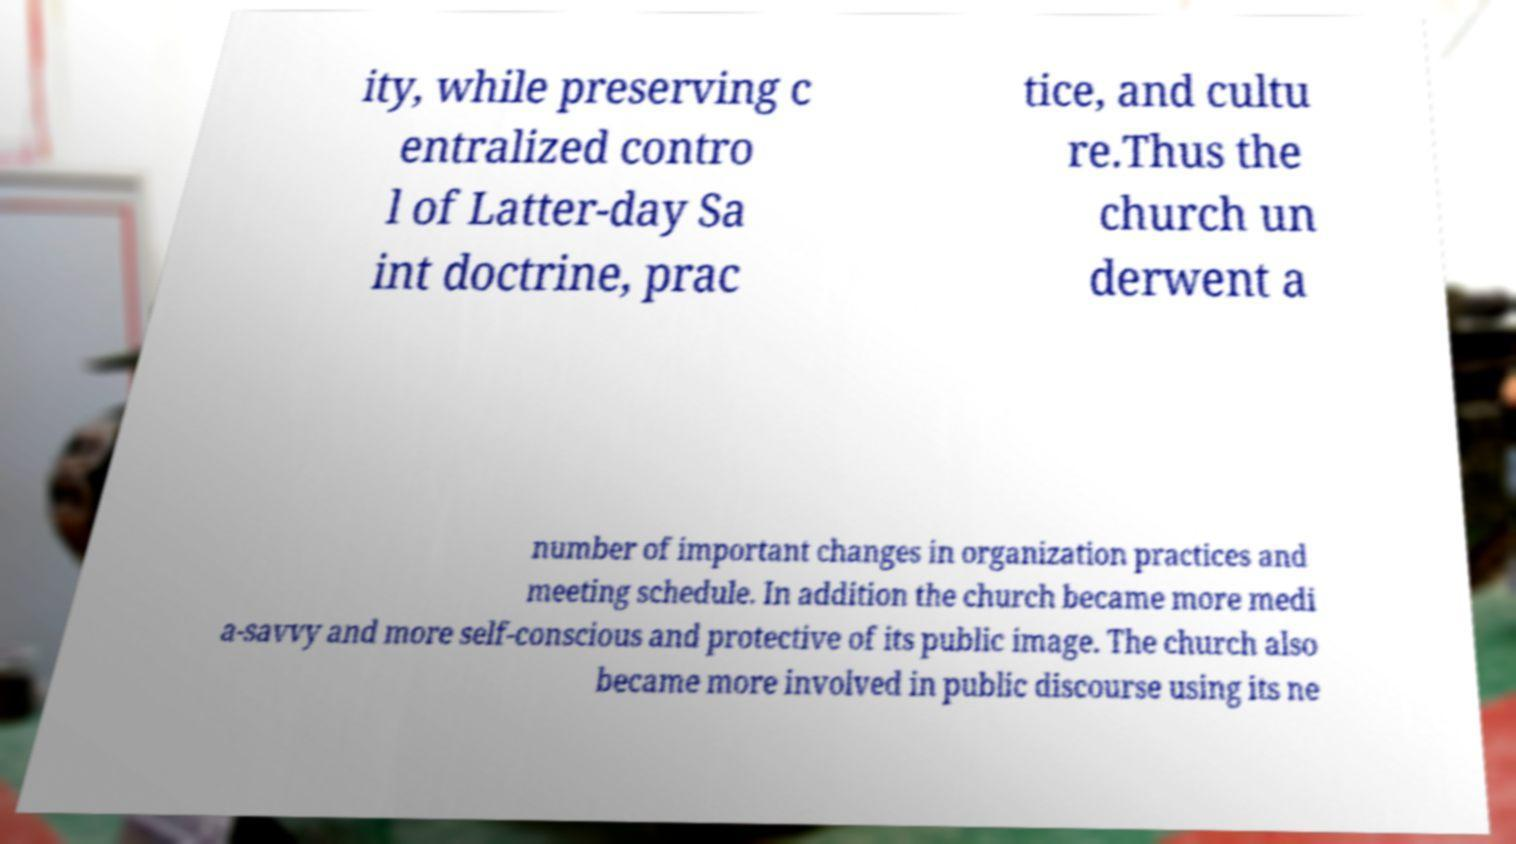Please identify and transcribe the text found in this image. ity, while preserving c entralized contro l of Latter-day Sa int doctrine, prac tice, and cultu re.Thus the church un derwent a number of important changes in organization practices and meeting schedule. In addition the church became more medi a-savvy and more self-conscious and protective of its public image. The church also became more involved in public discourse using its ne 